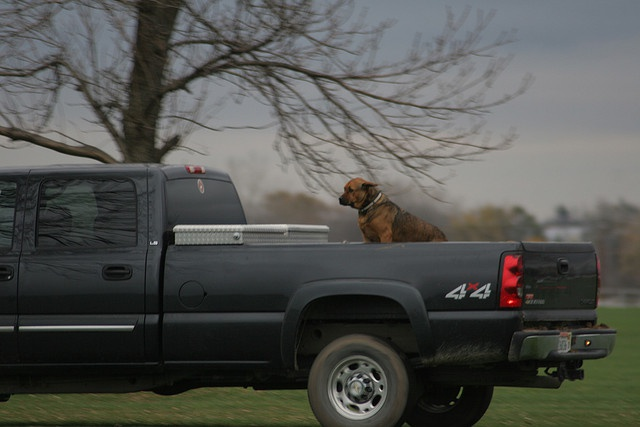Describe the objects in this image and their specific colors. I can see truck in gray, black, purple, and darkgray tones and dog in gray, black, and maroon tones in this image. 